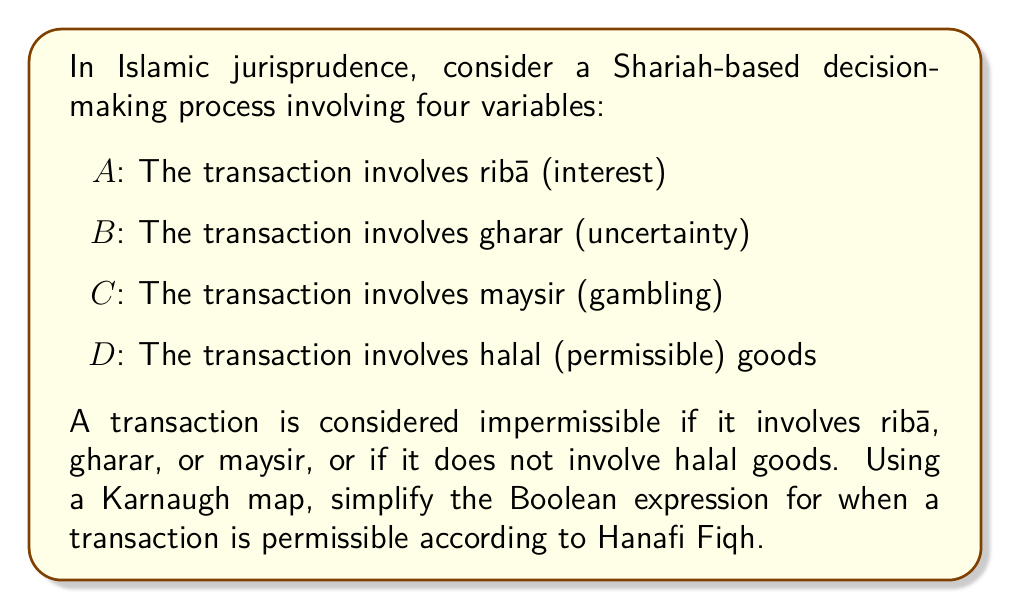Can you solve this math problem? Let's approach this step-by-step:

1) First, we need to create a truth table for the permissible transactions. A transaction is permissible when it does not involve ribā, gharar, or maysir, and involves halal goods. This can be represented as:

   $f(A,B,C,D) = \overline{A} \cdot \overline{B} \cdot \overline{C} \cdot D$

2) Now, let's create a 4-variable Karnaugh map:

   [asy]
   unitsize(1cm);
   for(int i=0; i<4; ++i)
     for(int j=0; j<4; ++j)
       draw((i,j)--(i+1,j)--(i+1,j+1)--(i,j+1)--cycle);
   label("AB$\backslash$CD", (-0.5,4.5));
   label("00", (0.5,4.5)); label("01", (1.5,4.5)); label("11", (2.5,4.5)); label("10", (3.5,4.5));
   label("00", (-0.5,3.5)); label("01", (-0.5,2.5)); label("11", (-0.5,1.5)); label("10", (-0.5,0.5));
   label("0", (0.5,3.5)); label("0", (1.5,3.5)); label("0", (2.5,3.5)); label("0", (3.5,3.5));
   label("0", (0.5,2.5)); label("1", (1.5,2.5)); label("0", (2.5,2.5)); label("0", (3.5,2.5));
   label("0", (0.5,1.5)); label("0", (1.5,1.5)); label("0", (2.5,1.5)); label("0", (3.5,1.5));
   label("0", (0.5,0.5)); label("0", (1.5,0.5)); label("0", (2.5,0.5)); label("0", (3.5,0.5));
   [/asy]

3) In this map, there's only one cell with a 1, corresponding to $\overline{A}\overline{B}\overline{C}D$.

4) Since there are no adjacent 1s, no simplification is possible using the Karnaugh map method.

5) Therefore, the simplified Boolean expression for a permissible transaction remains:

   $f(A,B,C,D) = \overline{A} \cdot \overline{B} \cdot \overline{C} \cdot D$

This expression in words means: A transaction is permissible when it does not involve ribā (not A) AND does not involve gharar (not B) AND does not involve maysir (not C) AND involves halal goods (D).
Answer: $f(A,B,C,D) = \overline{A} \cdot \overline{B} \cdot \overline{C} \cdot D$ 